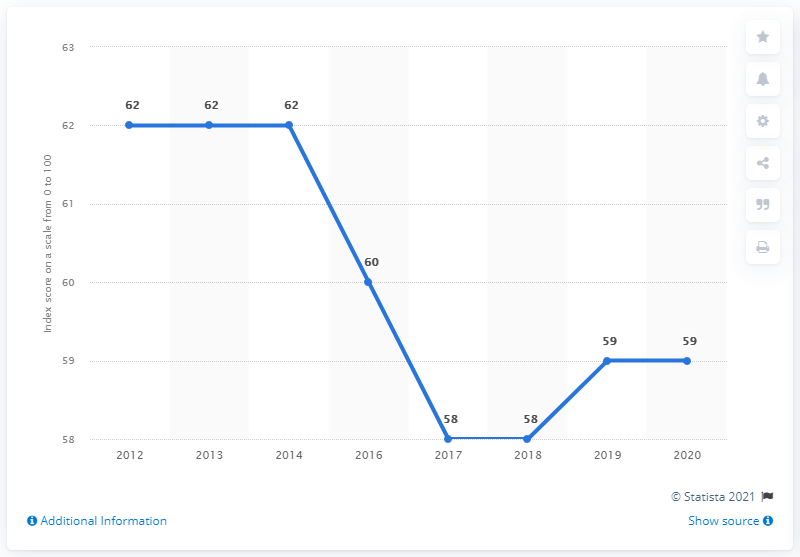Highlight a few significant elements in this photo. For how many years do the least values have the same value? The mode and the highest value are two different ways of describing the most common value and the highest value in a set of data, respectively. 